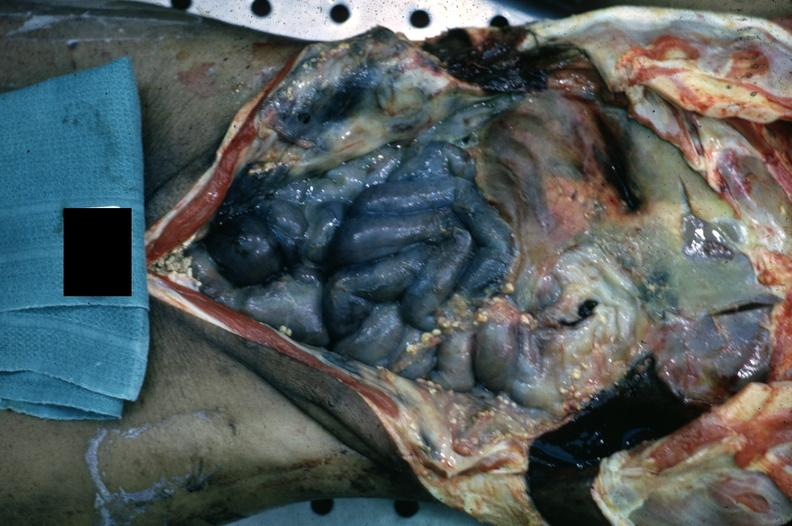s opened abdominal cavity with massive tumor in omentum none apparent in liver nor over peritoneal surfaces gut present?
Answer the question using a single word or phrase. No 